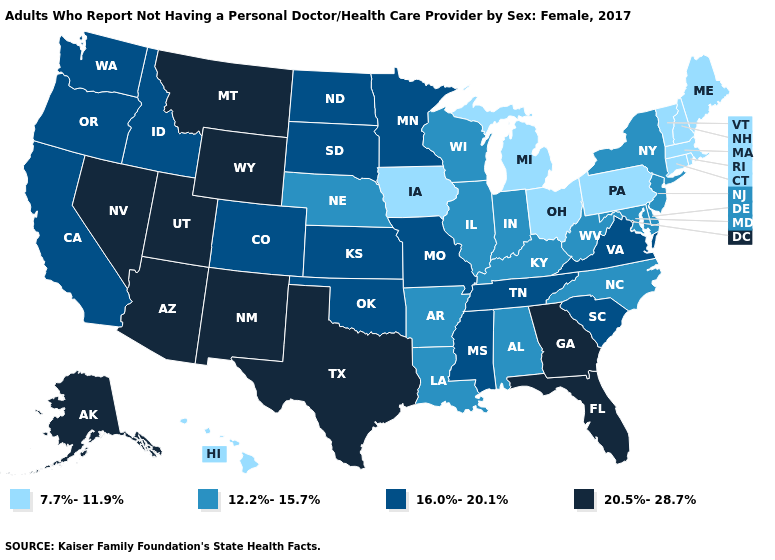What is the value of Nebraska?
Give a very brief answer. 12.2%-15.7%. Does Minnesota have a higher value than Louisiana?
Give a very brief answer. Yes. Which states have the lowest value in the Northeast?
Be succinct. Connecticut, Maine, Massachusetts, New Hampshire, Pennsylvania, Rhode Island, Vermont. Among the states that border Nebraska , does Iowa have the lowest value?
Give a very brief answer. Yes. What is the value of Florida?
Write a very short answer. 20.5%-28.7%. Which states have the lowest value in the USA?
Keep it brief. Connecticut, Hawaii, Iowa, Maine, Massachusetts, Michigan, New Hampshire, Ohio, Pennsylvania, Rhode Island, Vermont. What is the highest value in states that border South Dakota?
Short answer required. 20.5%-28.7%. Does New Jersey have the highest value in the Northeast?
Keep it brief. Yes. What is the value of California?
Write a very short answer. 16.0%-20.1%. Name the states that have a value in the range 16.0%-20.1%?
Give a very brief answer. California, Colorado, Idaho, Kansas, Minnesota, Mississippi, Missouri, North Dakota, Oklahoma, Oregon, South Carolina, South Dakota, Tennessee, Virginia, Washington. What is the value of West Virginia?
Concise answer only. 12.2%-15.7%. How many symbols are there in the legend?
Concise answer only. 4. Name the states that have a value in the range 7.7%-11.9%?
Be succinct. Connecticut, Hawaii, Iowa, Maine, Massachusetts, Michigan, New Hampshire, Ohio, Pennsylvania, Rhode Island, Vermont. What is the value of New Mexico?
Be succinct. 20.5%-28.7%. Which states have the lowest value in the West?
Concise answer only. Hawaii. 